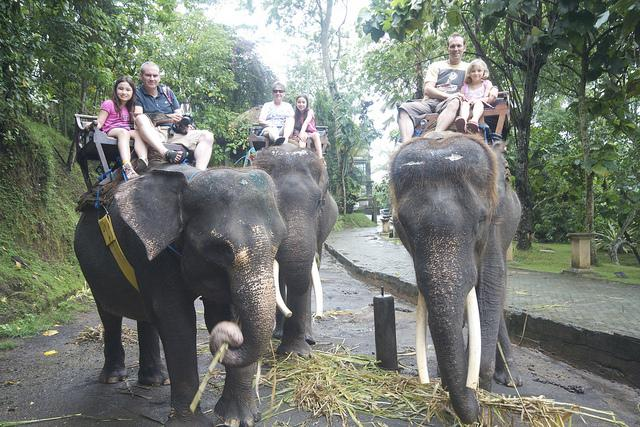What is hoisted atop the elephants to help the people ride them? Please explain your reasoning. benches. The people are sitting on a long seat made of wood with legs. 